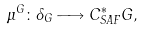Convert formula to latex. <formula><loc_0><loc_0><loc_500><loc_500>\mu ^ { G } \colon \Lambda _ { G } \longrightarrow C ^ { * } _ { S A F } G ,</formula> 